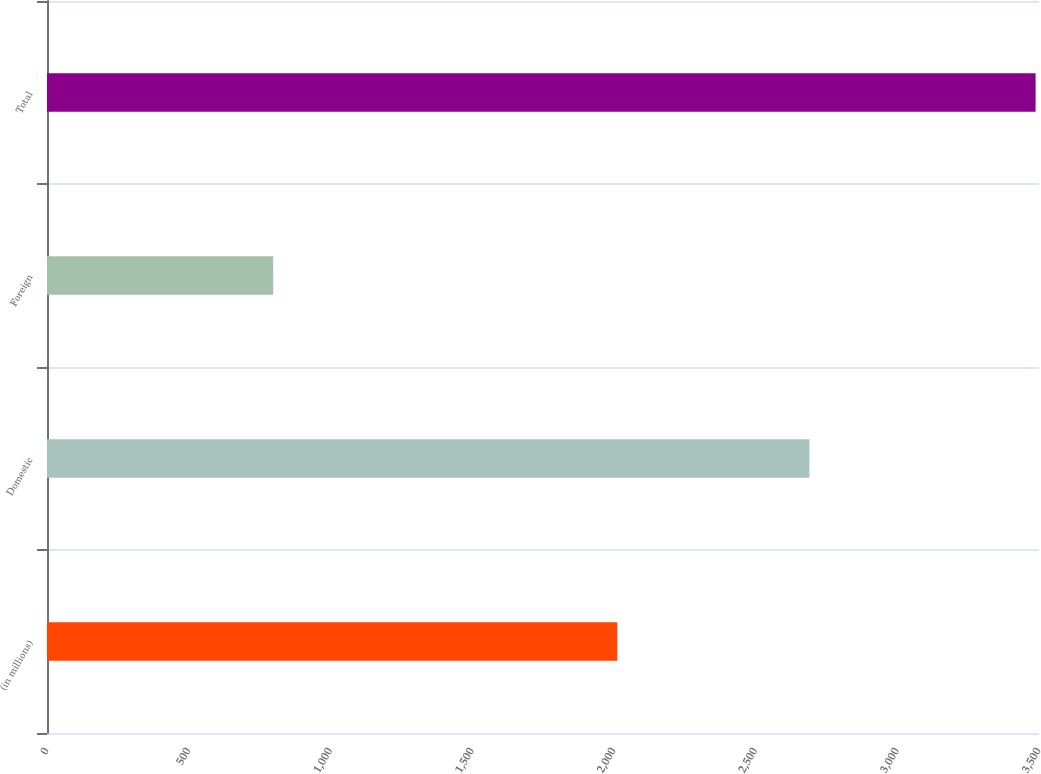<chart> <loc_0><loc_0><loc_500><loc_500><bar_chart><fcel>(in millions)<fcel>Domestic<fcel>Foreign<fcel>Total<nl><fcel>2012<fcel>2690<fcel>798<fcel>3488<nl></chart> 